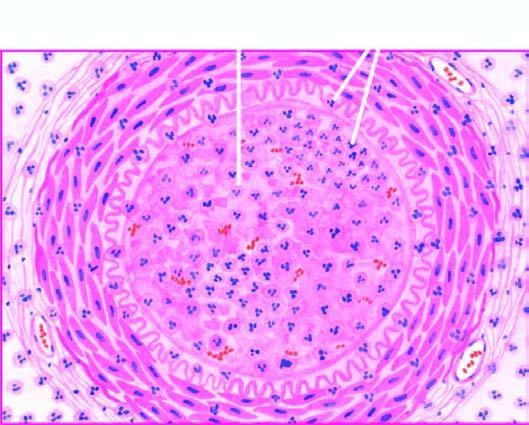s there acute panarteritis?
Answer the question using a single word or phrase. Yes 